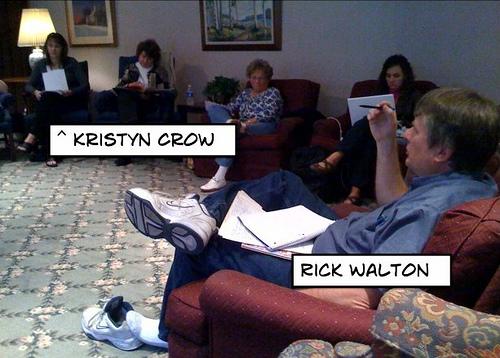What is in the pattern on the carpet made up of?
Quick response, please. Flowers. Is the lamp on?
Keep it brief. Yes. Which side shoe does the man have off?
Concise answer only. Left. 